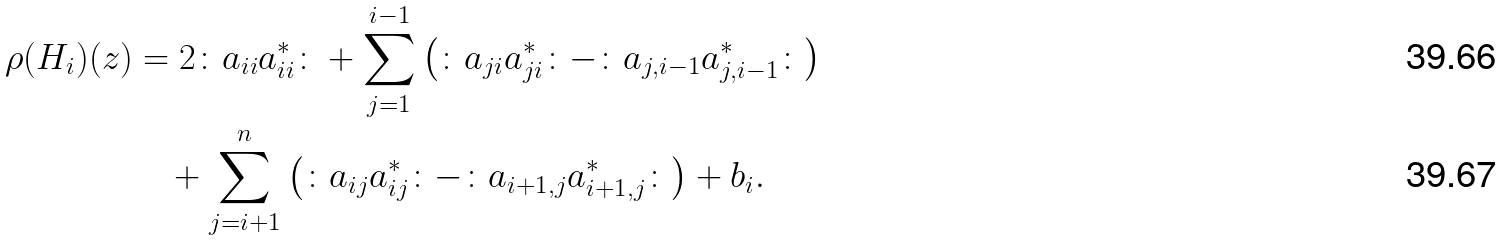<formula> <loc_0><loc_0><loc_500><loc_500>\rho ( H _ { i } ) ( z ) & = 2 \colon a _ { i i } a _ { i i } ^ { * } \colon + \sum _ { j = 1 } ^ { i - 1 } \left ( \colon a _ { j i } a _ { j i } ^ { * } \colon - \colon a _ { j , i - 1 } a _ { j , i - 1 } ^ { * } \colon \right ) \\ & \quad + \sum _ { j = i + 1 } ^ { n } \left ( \colon a _ { i j } a _ { i j } ^ { * } \colon - \colon a _ { i + 1 , j } a _ { i + 1 , j } ^ { * } \colon \right ) + b _ { i } .</formula> 